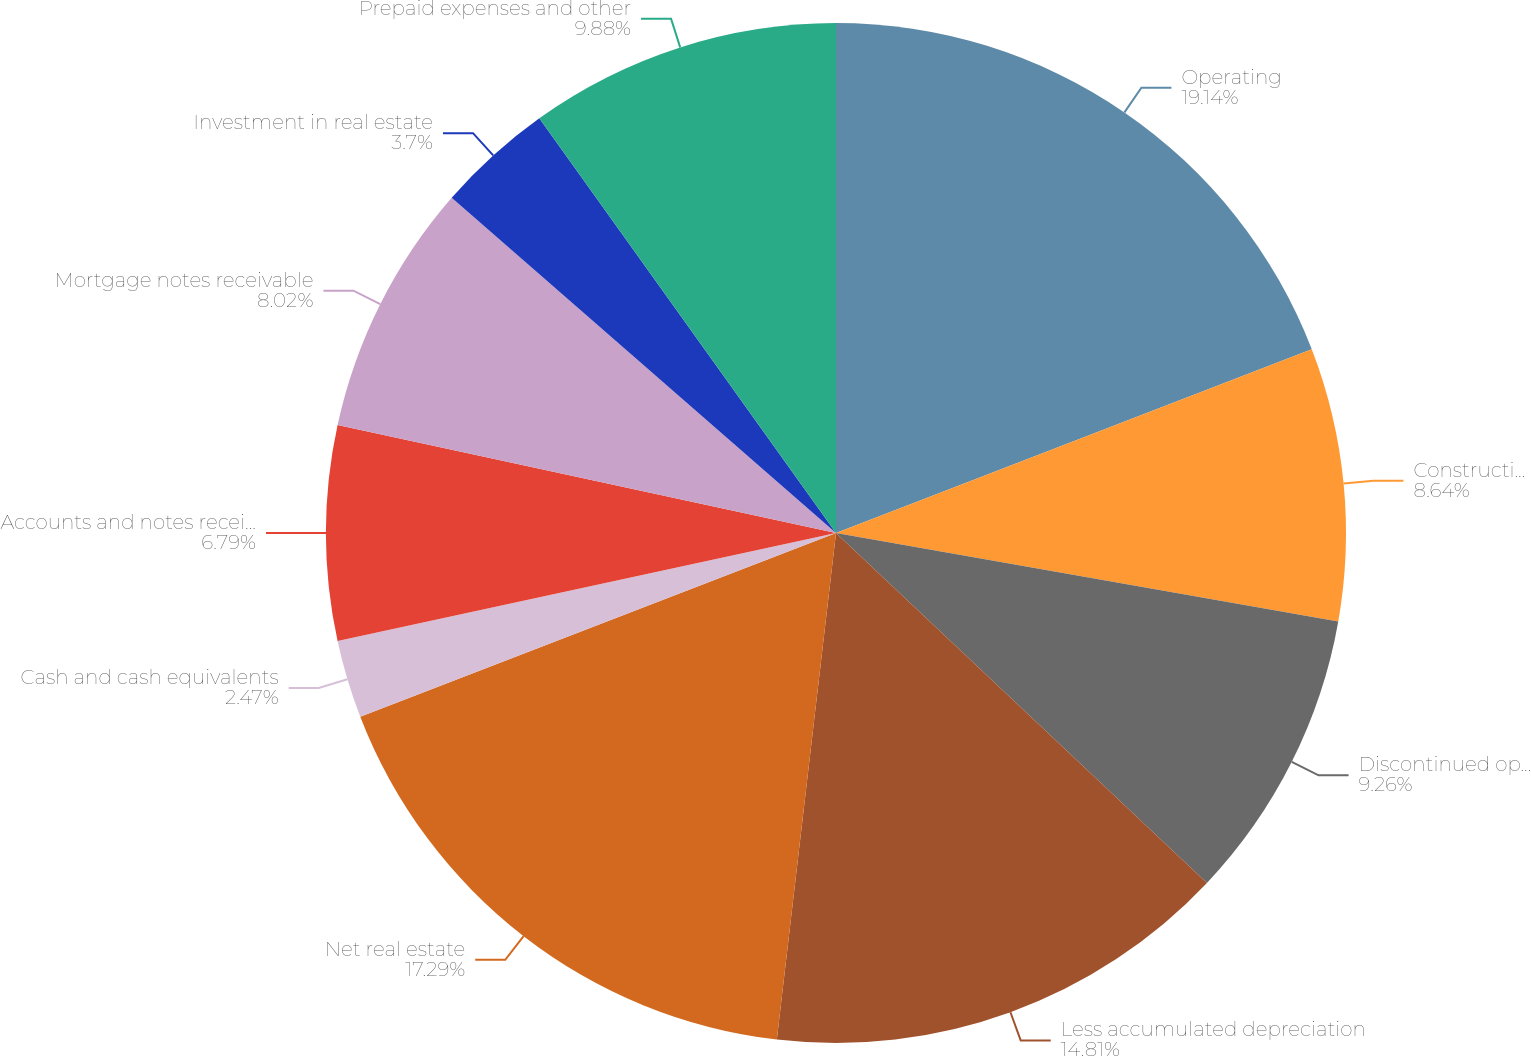Convert chart. <chart><loc_0><loc_0><loc_500><loc_500><pie_chart><fcel>Operating<fcel>Construction-in-progress<fcel>Discontinued operations<fcel>Less accumulated depreciation<fcel>Net real estate<fcel>Cash and cash equivalents<fcel>Accounts and notes receivable<fcel>Mortgage notes receivable<fcel>Investment in real estate<fcel>Prepaid expenses and other<nl><fcel>19.13%<fcel>8.64%<fcel>9.26%<fcel>14.81%<fcel>17.28%<fcel>2.47%<fcel>6.79%<fcel>8.02%<fcel>3.7%<fcel>9.88%<nl></chart> 